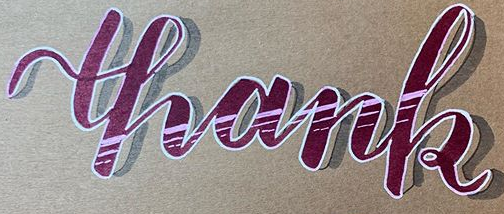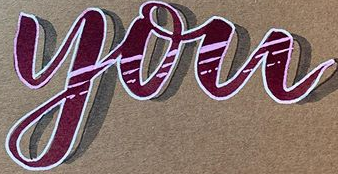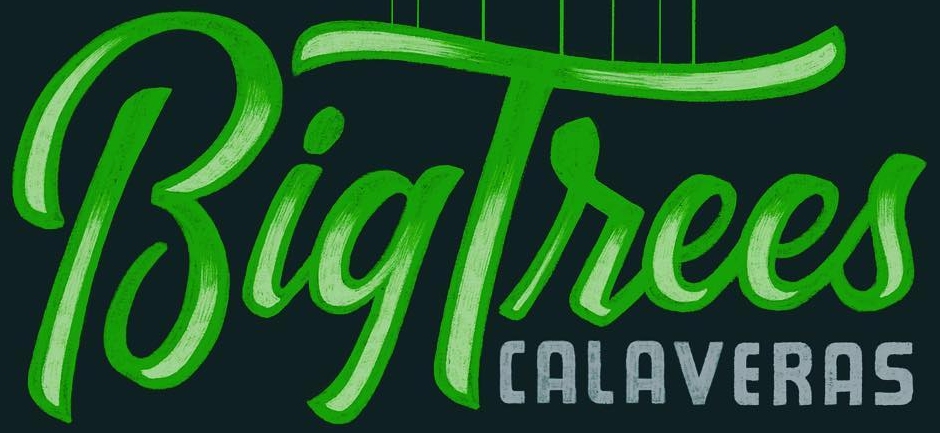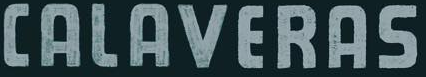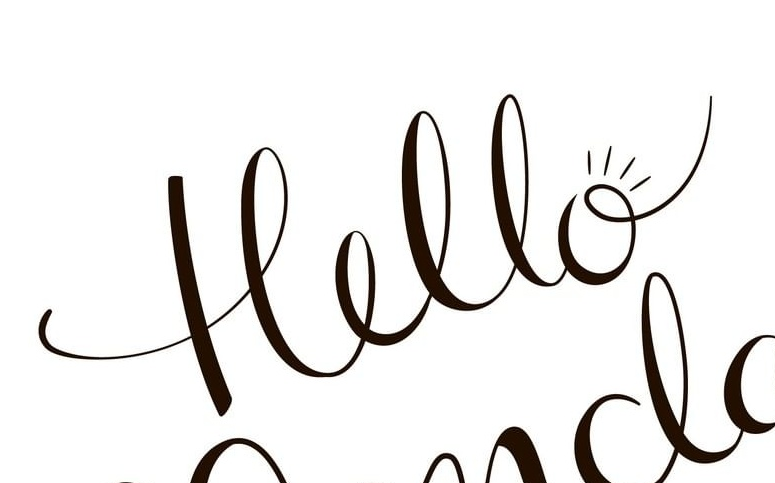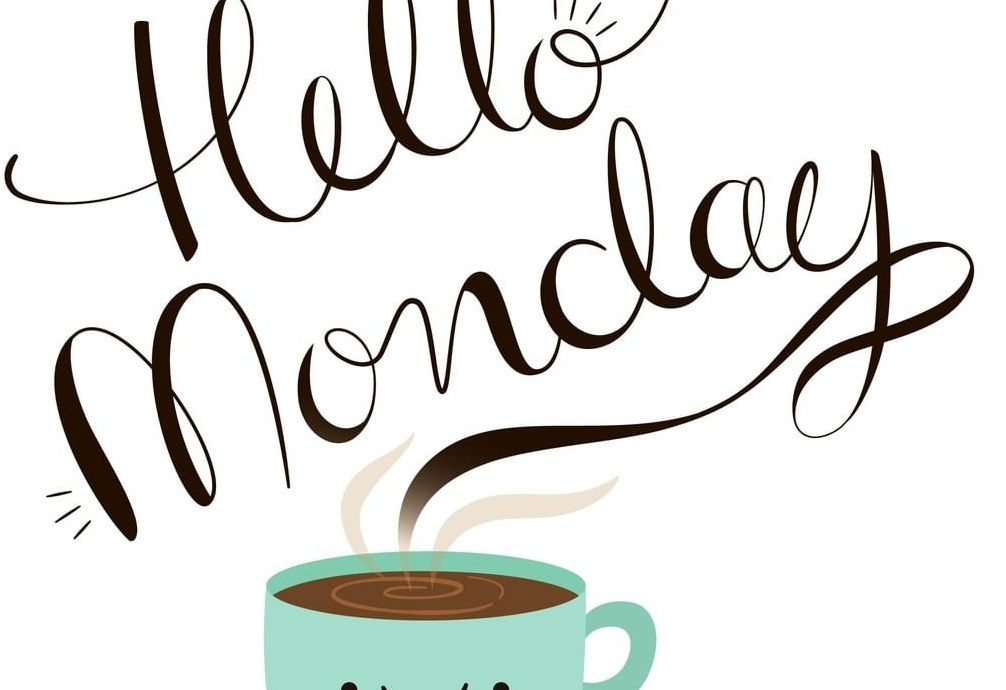What words can you see in these images in sequence, separated by a semicolon? thank; you; BigTrees; CALAVERAS; Hello; Monday 